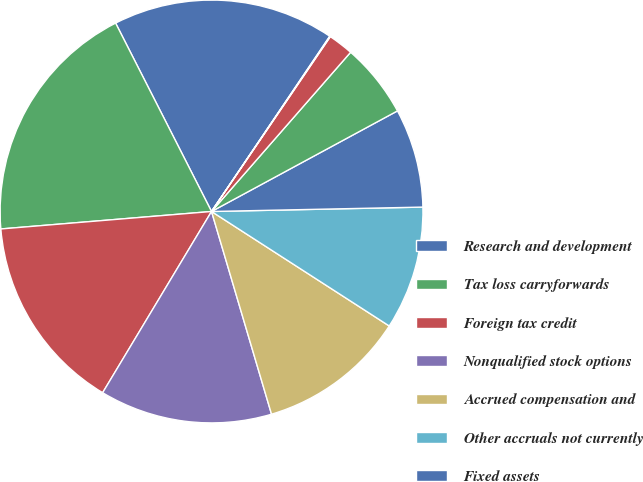Convert chart to OTSL. <chart><loc_0><loc_0><loc_500><loc_500><pie_chart><fcel>Research and development<fcel>Tax loss carryforwards<fcel>Foreign tax credit<fcel>Nonqualified stock options<fcel>Accrued compensation and<fcel>Other accruals not currently<fcel>Fixed assets<fcel>Capitalized research and<fcel>Reserves for product returns<fcel>Other<nl><fcel>16.94%<fcel>18.82%<fcel>15.07%<fcel>13.19%<fcel>11.31%<fcel>9.44%<fcel>7.56%<fcel>5.68%<fcel>1.93%<fcel>0.05%<nl></chart> 